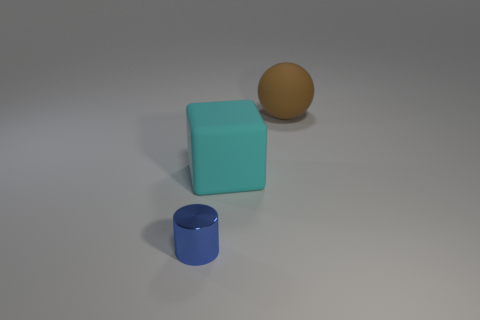There is a cyan matte thing in front of the brown object that is right of the big matte thing in front of the big brown rubber sphere; what shape is it?
Give a very brief answer. Cube. What number of things are tiny shiny objects or things right of the blue cylinder?
Offer a terse response. 3. There is a matte thing that is in front of the brown matte sphere; is it the same size as the large brown thing?
Your answer should be very brief. Yes. There is a object on the right side of the cyan thing; what is it made of?
Make the answer very short. Rubber. Are there an equal number of tiny metallic things that are in front of the small blue shiny thing and things that are on the left side of the large cyan thing?
Provide a short and direct response. No. Is there anything else that has the same color as the rubber sphere?
Make the answer very short. No. How many matte objects are either big gray balls or large brown things?
Offer a terse response. 1. Is the number of large brown matte things that are to the right of the tiny shiny thing greater than the number of large brown cylinders?
Ensure brevity in your answer.  Yes. What number of other objects are there of the same material as the brown thing?
Provide a short and direct response. 1. How many large objects are either cyan blocks or yellow metal spheres?
Your answer should be very brief. 1. 